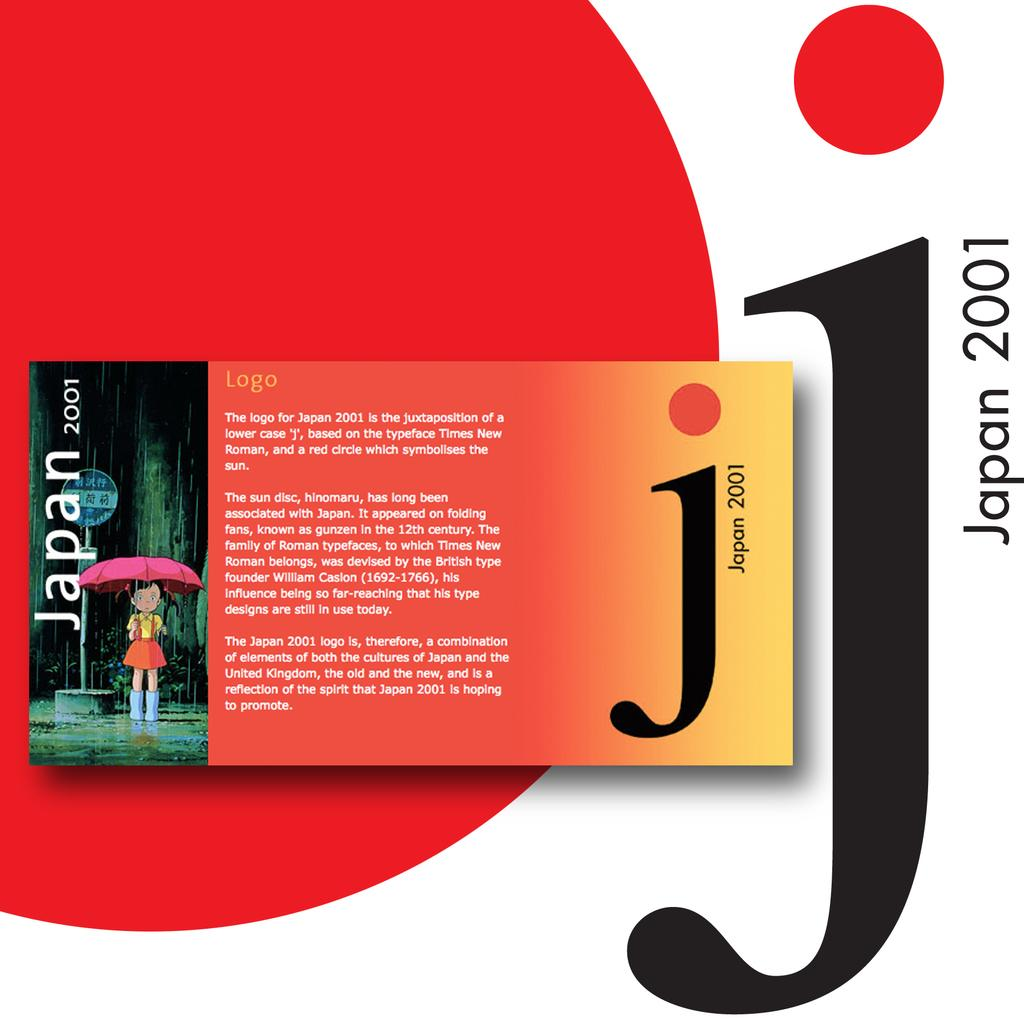What is the main subject of the logo in the image? The main subject of the logo in the image is a girl standing with an umbrella. What country and year does the logo represent? The logo represents Japan 2001. What else can be seen in the image besides the logo? There is a sign board in the image. How does the girl in the logo manage her pain while holding the umbrella? There is no indication of pain in the image, as the girl is simply standing with an umbrella. Is there a zipper on the girl's clothing in the logo? The girl's clothing in the logo does not have a visible zipper. 